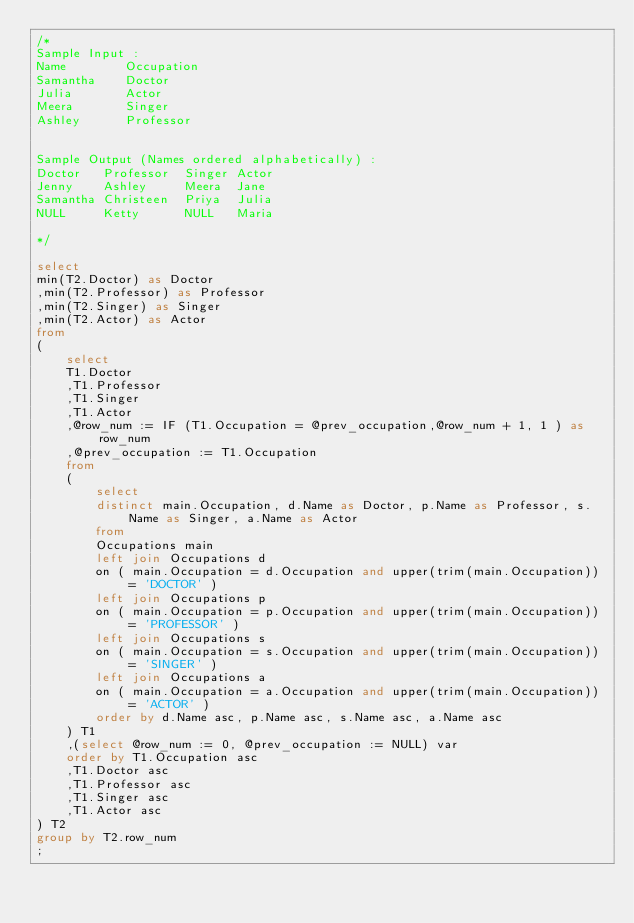<code> <loc_0><loc_0><loc_500><loc_500><_SQL_>/*
Sample Input :
Name        Occupation
Samantha    Doctor
Julia       Actor
Meera       Singer
Ashley      Professor


Sample Output (Names ordered alphabetically) :
Doctor   Professor  Singer Actor 
Jenny    Ashley     Meera  Jane
Samantha Christeen  Priya  Julia
NULL     Ketty      NULL   Maria

*/

select
min(T2.Doctor) as Doctor
,min(T2.Professor) as Professor
,min(T2.Singer) as Singer
,min(T2.Actor) as Actor
from
(
    select 
    T1.Doctor
    ,T1.Professor
    ,T1.Singer
    ,T1.Actor
    ,@row_num := IF (T1.Occupation = @prev_occupation,@row_num + 1, 1 ) as row_num
    ,@prev_occupation := T1.Occupation
    from
    (
        select
        distinct main.Occupation, d.Name as Doctor, p.Name as Professor, s.Name as Singer, a.Name as Actor
        from
        Occupations main
        left join Occupations d
        on ( main.Occupation = d.Occupation and upper(trim(main.Occupation)) = 'DOCTOR' )
        left join Occupations p
        on ( main.Occupation = p.Occupation and upper(trim(main.Occupation)) = 'PROFESSOR' )
        left join Occupations s
        on ( main.Occupation = s.Occupation and upper(trim(main.Occupation)) = 'SINGER' )
        left join Occupations a
        on ( main.Occupation = a.Occupation and upper(trim(main.Occupation)) = 'ACTOR' )
        order by d.Name asc, p.Name asc, s.Name asc, a.Name asc
    ) T1
    ,(select @row_num := 0, @prev_occupation := NULL) var
    order by T1.Occupation asc
    ,T1.Doctor asc
    ,T1.Professor asc
    ,T1.Singer asc
    ,T1.Actor asc    
) T2 
group by T2.row_num
;</code> 